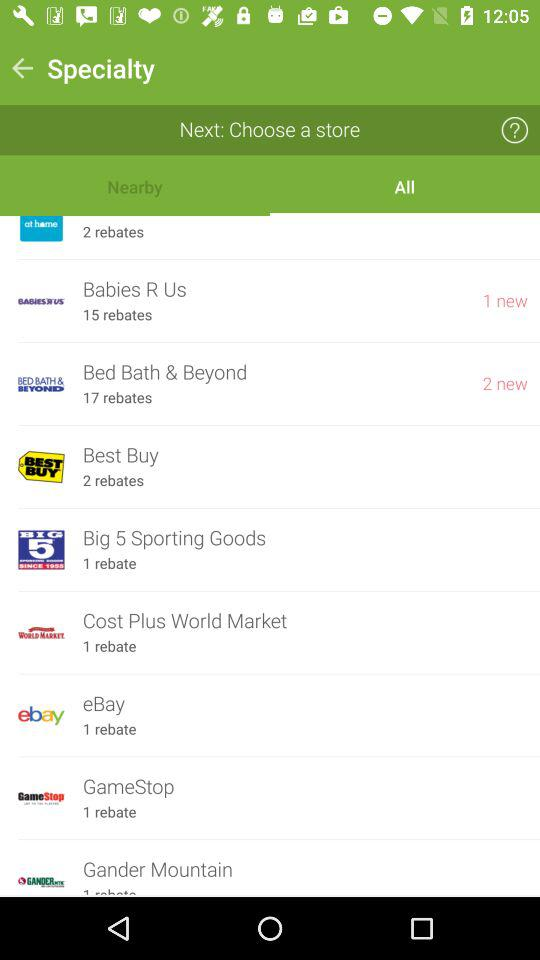Which tab is selected in "Specialty"? The selected tab is "All". 